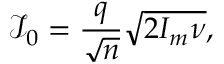Convert formula to latex. <formula><loc_0><loc_0><loc_500><loc_500>\mathcal { I } _ { 0 } = \frac { q } { \sqrt { n } } \sqrt { 2 I _ { m } \nu } ,</formula> 